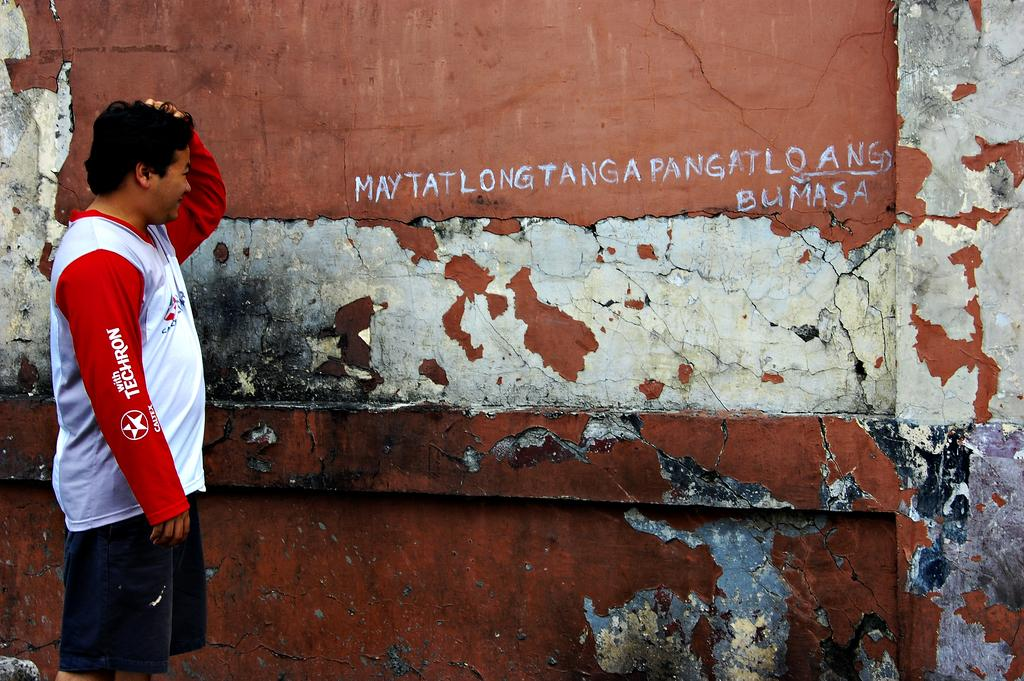<image>
Summarize the visual content of the image. a man standing outside with the word may written on the wall 